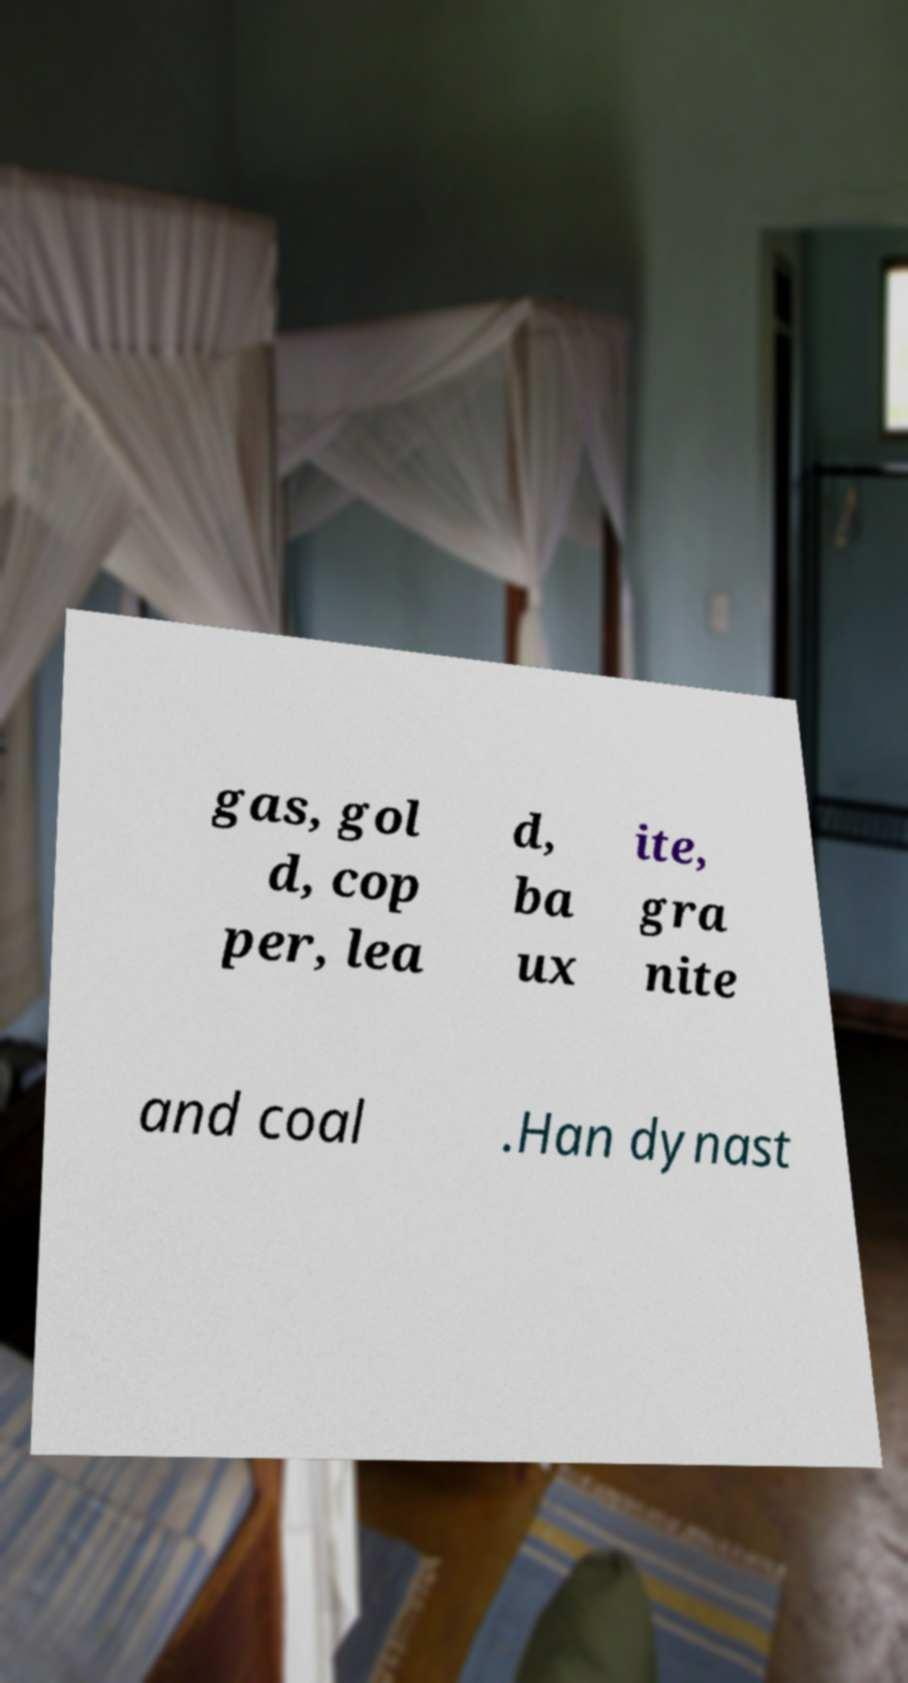Could you assist in decoding the text presented in this image and type it out clearly? gas, gol d, cop per, lea d, ba ux ite, gra nite and coal .Han dynast 